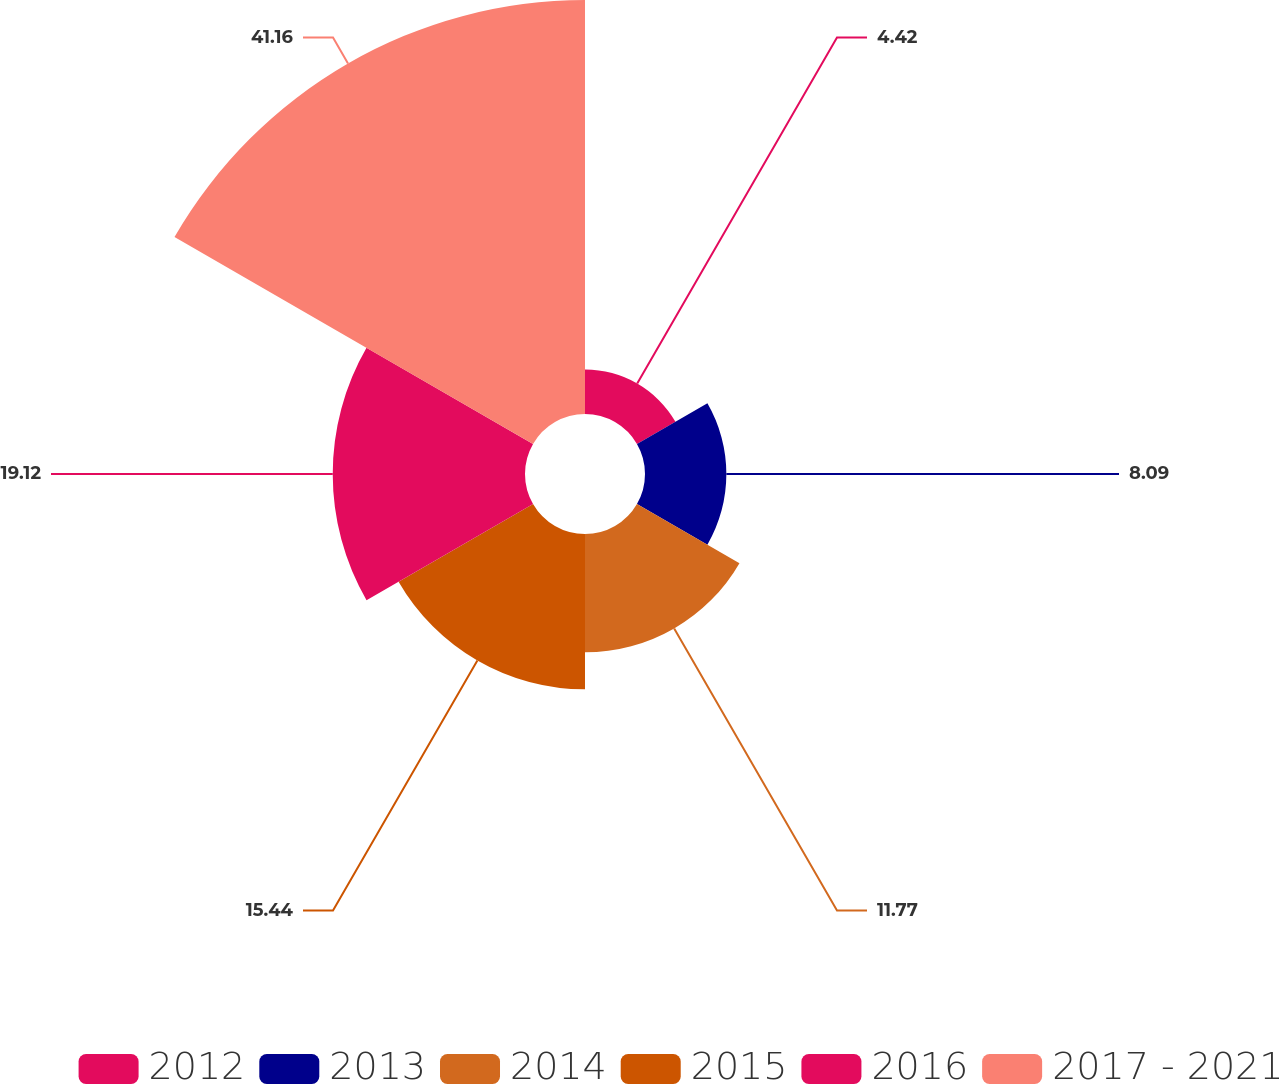<chart> <loc_0><loc_0><loc_500><loc_500><pie_chart><fcel>2012<fcel>2013<fcel>2014<fcel>2015<fcel>2016<fcel>2017 - 2021<nl><fcel>4.42%<fcel>8.09%<fcel>11.77%<fcel>15.44%<fcel>19.12%<fcel>41.17%<nl></chart> 